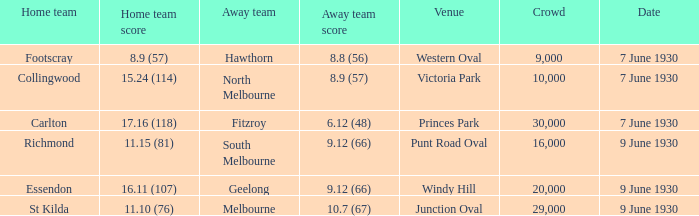7 (67)? 29000.0. 